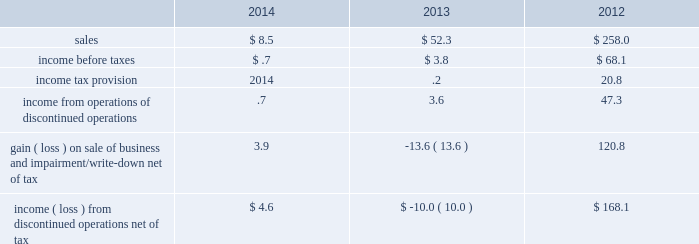Discontinued operations during the second quarter of 2012 , the board of directors authorized the sale of our homecare business , which had previously been reported as part of the merchant gases operating segment .
This business has been accounted for as a discontinued operation .
In the third quarter of 2012 , we sold the majority of our homecare business to the linde group for sale proceeds of 20ac590 million ( $ 777 ) and recognized a gain of $ 207.4 ( $ 150.3 after-tax , or $ .70 per share ) .
The sale proceeds included 20ac110 million ( $ 144 ) that was contingent on the outcome of certain retender arrangements .
These proceeds were reflected in payables and accrued liabilities on our consolidated balance sheet as of 30 september 2013 .
Based on the outcome of the retenders , we were contractually required to return proceeds to the linde group .
In the fourth quarter of 2014 , we made a payment to settle this liability and recognized a gain of $ 1.5 .
During the third quarter of 2012 , an impairment charge of $ 33.5 ( $ 29.5 after-tax , or $ .14 per share ) was recorded to write down the remaining business , which was primarily in the united kingdom and ireland , to its estimated net realizable value .
In the fourth quarter of 2013 , an additional charge of $ 18.7 ( $ 13.6 after-tax , or $ .06 per share ) was recorded to update our estimate of the net realizable value .
In the first quarter of 2014 , we sold the remaining portion of the homecare business for a36.1 million ( $ 9.8 ) and recorded a gain on sale of $ 2.4 .
We entered into an operations guarantee related to the obligations under certain homecare contracts assigned in connection with the transaction .
Refer to note 16 , commitments and contingencies , for additional information .
The results of discontinued operations are summarized below: .
The assets and liabilities classified as discontinued operations for the homecare business at 30 september 2013 consisted of $ 2.5 in trade receivables , net , and $ 2.4 in payables and accrued liabilities .
As of 30 september 2014 , no assets or liabilities were classified as discontinued operations. .
Considering the year 2014 , what is the percentage of income from operations of discontinued operations concerning income from discontinued operations net of tax? 
Rationale: it is the value of the income from operations of discontinued operations divided by the total income from discontinued operations net of tax's , then turned into a percentage .
Computations: (.7 / 4.6)
Answer: 0.15217. 